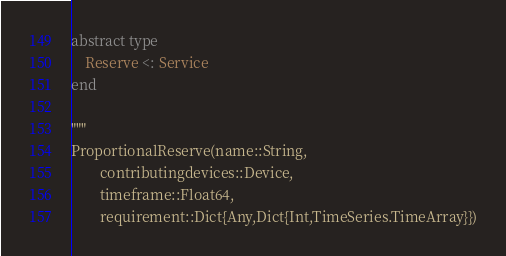<code> <loc_0><loc_0><loc_500><loc_500><_Julia_>
abstract type
    Reserve <: Service
end

"""
ProportionalReserve(name::String,
        contributingdevices::Device,
        timeframe::Float64,
        requirement::Dict{Any,Dict{Int,TimeSeries.TimeArray}})
</code> 